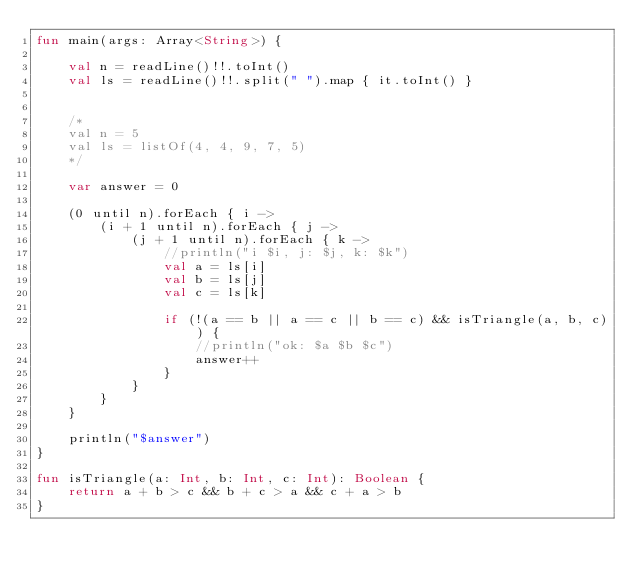Convert code to text. <code><loc_0><loc_0><loc_500><loc_500><_Kotlin_>fun main(args: Array<String>) {

    val n = readLine()!!.toInt()
    val ls = readLine()!!.split(" ").map { it.toInt() }


    /*
    val n = 5
    val ls = listOf(4, 4, 9, 7, 5)
    */

    var answer = 0

    (0 until n).forEach { i ->
        (i + 1 until n).forEach { j ->
            (j + 1 until n).forEach { k ->
                //println("i $i, j: $j, k: $k")
                val a = ls[i]
                val b = ls[j]
                val c = ls[k]

                if (!(a == b || a == c || b == c) && isTriangle(a, b, c)) {
                    //println("ok: $a $b $c")
                    answer++
                }
            }
        }
    }

    println("$answer")
}

fun isTriangle(a: Int, b: Int, c: Int): Boolean {
    return a + b > c && b + c > a && c + a > b
}
</code> 